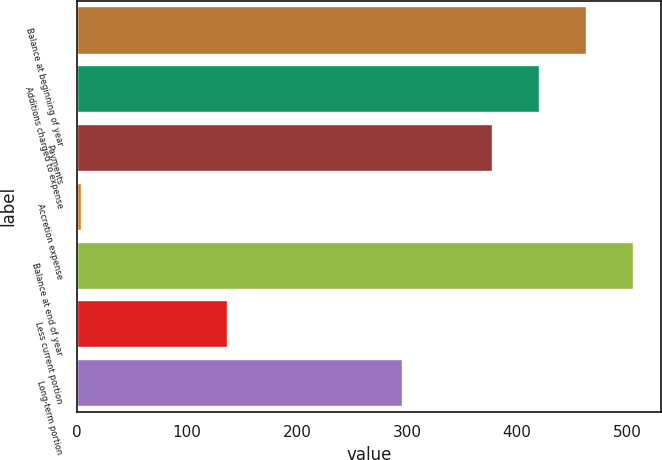<chart> <loc_0><loc_0><loc_500><loc_500><bar_chart><fcel>Balance at beginning of year<fcel>Additions charged to expense<fcel>Payments<fcel>Accretion expense<fcel>Balance at end of year<fcel>Less current portion<fcel>Long-term portion<nl><fcel>462.86<fcel>420.03<fcel>377.2<fcel>3.2<fcel>505.69<fcel>136.6<fcel>294.9<nl></chart> 